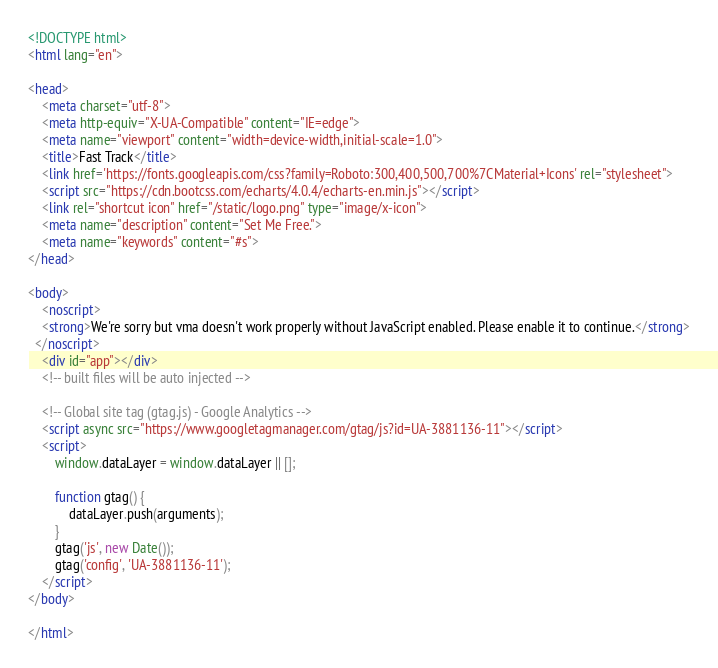<code> <loc_0><loc_0><loc_500><loc_500><_HTML_><!DOCTYPE html>
<html lang="en">

<head>
    <meta charset="utf-8">
    <meta http-equiv="X-UA-Compatible" content="IE=edge">
    <meta name="viewport" content="width=device-width,initial-scale=1.0">
    <title>Fast Track</title>
    <link href='https://fonts.googleapis.com/css?family=Roboto:300,400,500,700%7CMaterial+Icons' rel="stylesheet">
    <script src="https://cdn.bootcss.com/echarts/4.0.4/echarts-en.min.js"></script>
    <link rel="shortcut icon" href="/static/logo.png" type="image/x-icon">
    <meta name="description" content="Set Me Free.">
    <meta name="keywords" content="#s">
</head>

<body>
    <noscript>
    <strong>We're sorry but vma doesn't work properly without JavaScript enabled. Please enable it to continue.</strong>
  </noscript>
    <div id="app"></div>
    <!-- built files will be auto injected -->

    <!-- Global site tag (gtag.js) - Google Analytics -->
    <script async src="https://www.googletagmanager.com/gtag/js?id=UA-3881136-11"></script>
    <script>
        window.dataLayer = window.dataLayer || [];

        function gtag() {
            dataLayer.push(arguments);
        }
        gtag('js', new Date());
        gtag('config', 'UA-3881136-11');
    </script>
</body>

</html></code> 